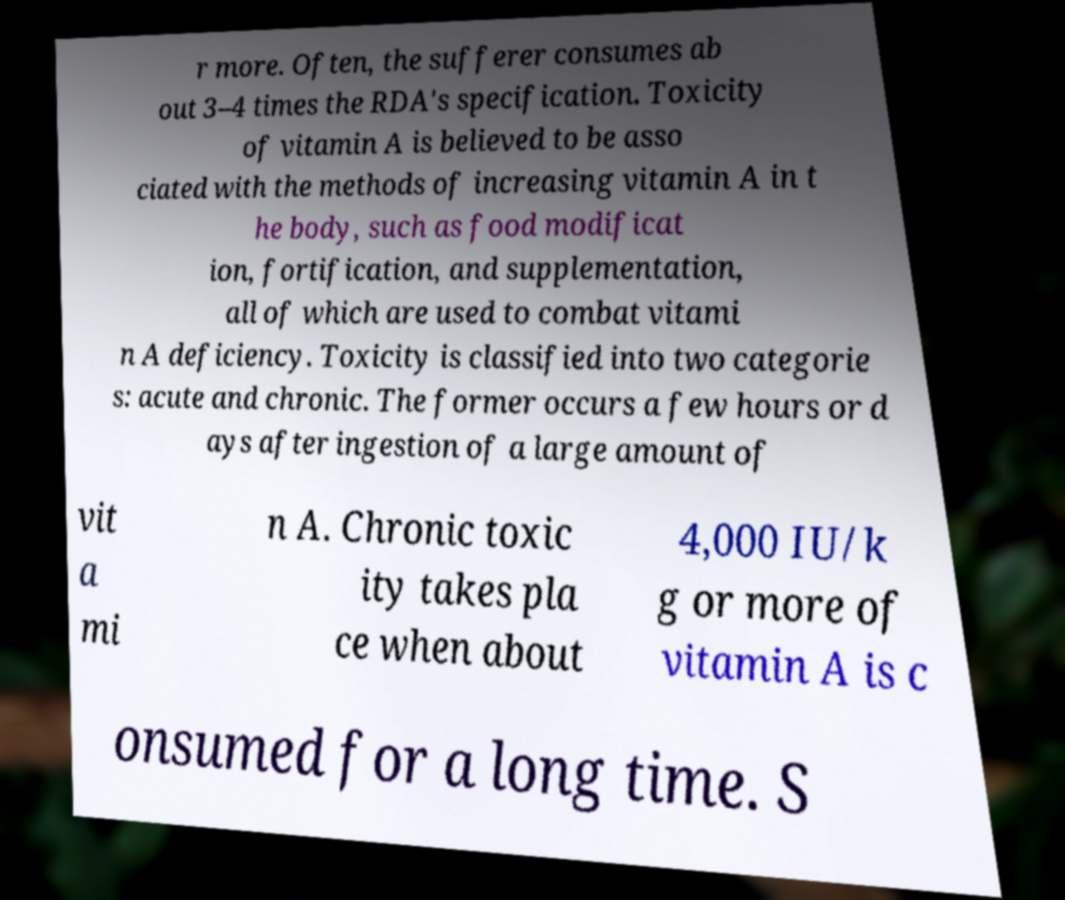Could you extract and type out the text from this image? r more. Often, the sufferer consumes ab out 3–4 times the RDA's specification. Toxicity of vitamin A is believed to be asso ciated with the methods of increasing vitamin A in t he body, such as food modificat ion, fortification, and supplementation, all of which are used to combat vitami n A deficiency. Toxicity is classified into two categorie s: acute and chronic. The former occurs a few hours or d ays after ingestion of a large amount of vit a mi n A. Chronic toxic ity takes pla ce when about 4,000 IU/k g or more of vitamin A is c onsumed for a long time. S 